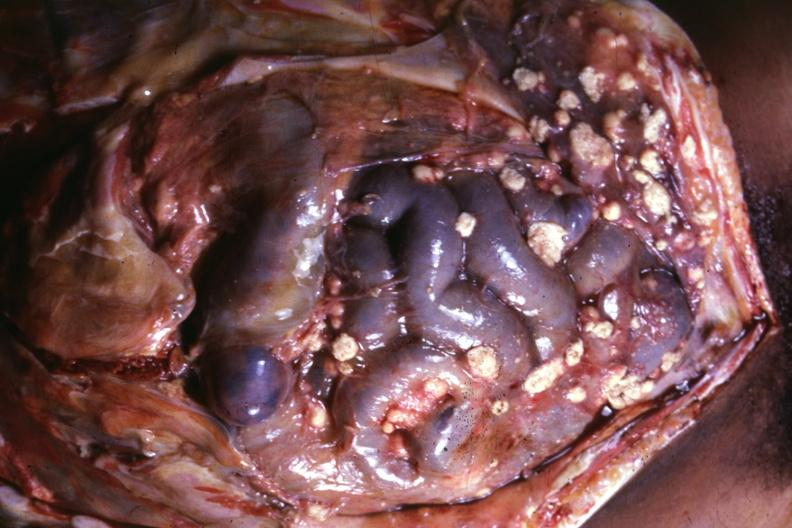s omphalocele present?
Answer the question using a single word or phrase. No 